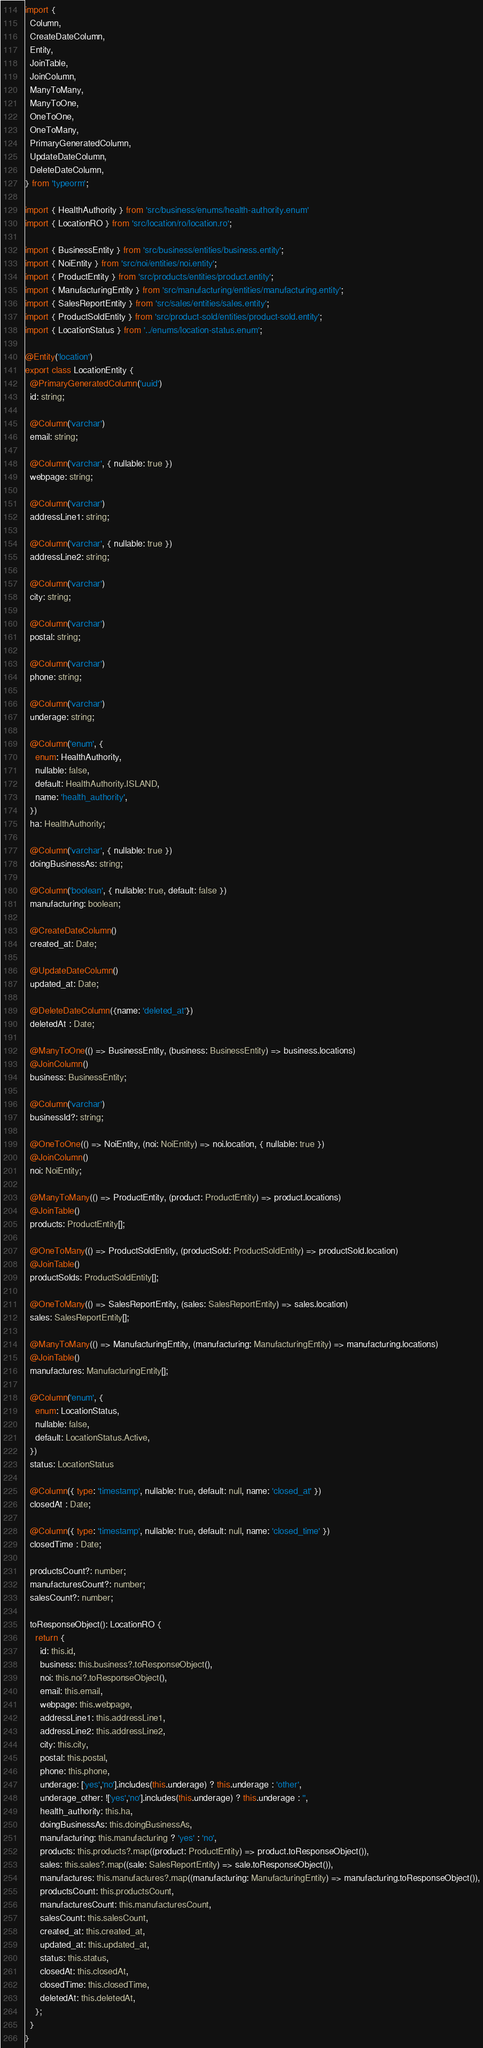<code> <loc_0><loc_0><loc_500><loc_500><_TypeScript_>import {
  Column,
  CreateDateColumn,
  Entity,
  JoinTable,
  JoinColumn,
  ManyToMany,
  ManyToOne,
  OneToOne,
  OneToMany,
  PrimaryGeneratedColumn,
  UpdateDateColumn,
  DeleteDateColumn,
} from 'typeorm';

import { HealthAuthority } from 'src/business/enums/health-authority.enum'
import { LocationRO } from 'src/location/ro/location.ro';

import { BusinessEntity } from 'src/business/entities/business.entity';
import { NoiEntity } from 'src/noi/entities/noi.entity';
import { ProductEntity } from 'src/products/entities/product.entity';
import { ManufacturingEntity } from 'src/manufacturing/entities/manufacturing.entity';
import { SalesReportEntity } from 'src/sales/entities/sales.entity';
import { ProductSoldEntity } from 'src/product-sold/entities/product-sold.entity';
import { LocationStatus } from '../enums/location-status.enum';

@Entity('location')
export class LocationEntity {
  @PrimaryGeneratedColumn('uuid')
  id: string;

  @Column('varchar')
  email: string;

  @Column('varchar', { nullable: true })
  webpage: string;

  @Column('varchar')
  addressLine1: string;

  @Column('varchar', { nullable: true })
  addressLine2: string;

  @Column('varchar')
  city: string;

  @Column('varchar')
  postal: string;

  @Column('varchar')
  phone: string;

  @Column('varchar')
  underage: string;

  @Column('enum', {
    enum: HealthAuthority,
    nullable: false,
    default: HealthAuthority.ISLAND,
    name: 'health_authority',
  })
  ha: HealthAuthority;

  @Column('varchar', { nullable: true })
  doingBusinessAs: string;

  @Column('boolean', { nullable: true, default: false })
  manufacturing: boolean;

  @CreateDateColumn()
  created_at: Date;

  @UpdateDateColumn()
  updated_at: Date;

  @DeleteDateColumn({name: 'deleted_at'})
  deletedAt : Date;

  @ManyToOne(() => BusinessEntity, (business: BusinessEntity) => business.locations)
  @JoinColumn()
  business: BusinessEntity;

  @Column('varchar')
  businessId?: string;

  @OneToOne(() => NoiEntity, (noi: NoiEntity) => noi.location, { nullable: true })
  @JoinColumn()
  noi: NoiEntity;

  @ManyToMany(() => ProductEntity, (product: ProductEntity) => product.locations)
  @JoinTable()
  products: ProductEntity[];

  @OneToMany(() => ProductSoldEntity, (productSold: ProductSoldEntity) => productSold.location)
  @JoinTable()
  productSolds: ProductSoldEntity[];

  @OneToMany(() => SalesReportEntity, (sales: SalesReportEntity) => sales.location)
  sales: SalesReportEntity[];

  @ManyToMany(() => ManufacturingEntity, (manufacturing: ManufacturingEntity) => manufacturing.locations)
  @JoinTable()
  manufactures: ManufacturingEntity[];

  @Column('enum', {
    enum: LocationStatus,
    nullable: false,
    default: LocationStatus.Active,
  })
  status: LocationStatus

  @Column({ type: 'timestamp', nullable: true, default: null, name: 'closed_at' })
  closedAt : Date;

  @Column({ type: 'timestamp', nullable: true, default: null, name: 'closed_time' })
  closedTime : Date;

  productsCount?: number;
  manufacturesCount?: number;
  salesCount?: number;

  toResponseObject(): LocationRO {
    return {
      id: this.id,
      business: this.business?.toResponseObject(),
      noi: this.noi?.toResponseObject(),
      email: this.email,
      webpage: this.webpage,
      addressLine1: this.addressLine1,
      addressLine2: this.addressLine2,
      city: this.city,
      postal: this.postal,
      phone: this.phone,
      underage: ['yes','no'].includes(this.underage) ? this.underage : 'other',
      underage_other: !['yes','no'].includes(this.underage) ? this.underage : '',
      health_authority: this.ha,
      doingBusinessAs: this.doingBusinessAs,
      manufacturing: this.manufacturing ? 'yes' : 'no',
      products: this.products?.map((product: ProductEntity) => product.toResponseObject()),
      sales: this.sales?.map((sale: SalesReportEntity) => sale.toResponseObject()),
      manufactures: this.manufactures?.map((manufacturing: ManufacturingEntity) => manufacturing.toResponseObject()),
      productsCount: this.productsCount,
      manufacturesCount: this.manufacturesCount,
      salesCount: this.salesCount,
      created_at: this.created_at,
      updated_at: this.updated_at,
      status: this.status,
      closedAt: this.closedAt,
      closedTime: this.closedTime,
      deletedAt: this.deletedAt,
    };
  }
}
</code> 